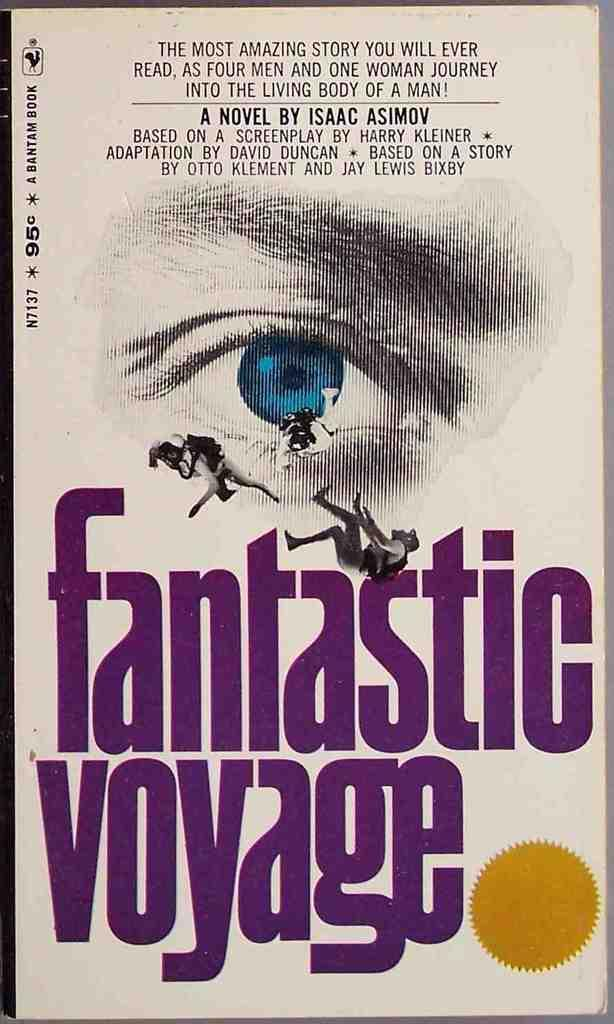<image>
Create a compact narrative representing the image presented. Fantastic Voyage vintage book by Bantam Book with a eye logo. 